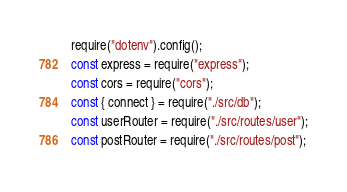<code> <loc_0><loc_0><loc_500><loc_500><_JavaScript_>require("dotenv").config();
const express = require("express");
const cors = require("cors");
const { connect } = require("./src/db");
const userRouter = require("./src/routes/user");
const postRouter = require("./src/routes/post");
</code> 